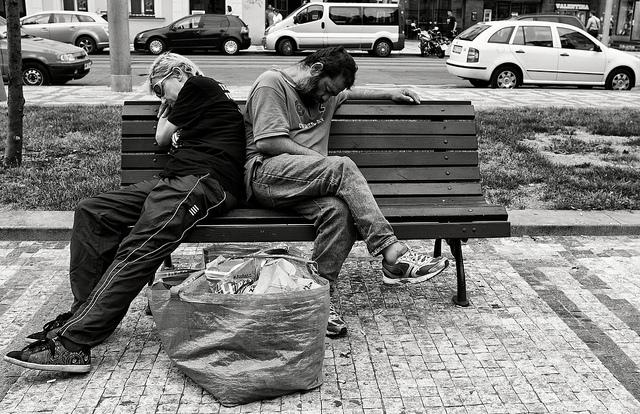What vehicle on the north side of the street will the car traveling west pass second? Please explain your reasoning. white van. The white van is going to be passed second. 